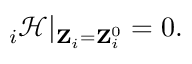<formula> <loc_0><loc_0><loc_500><loc_500>{ \nabla } _ { i } \mathcal { H } | _ { { Z } _ { i } = { Z } _ { i } ^ { 0 } } = 0 .</formula> 